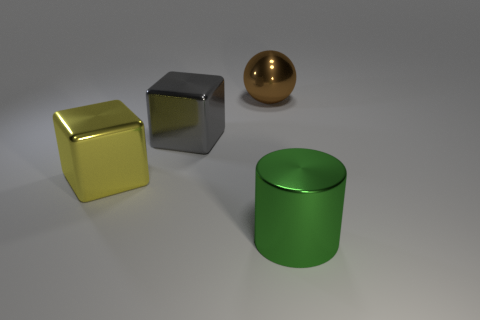Is the number of gray metallic objects to the left of the gray shiny object the same as the number of purple shiny blocks?
Ensure brevity in your answer.  Yes. What shape is the large metallic thing that is in front of the gray metal cube and on the left side of the brown ball?
Your response must be concise. Cube. Do the gray thing and the green shiny cylinder have the same size?
Your answer should be very brief. Yes. Is there a big purple sphere made of the same material as the large brown sphere?
Your answer should be compact. No. How many things are in front of the large brown ball and right of the big yellow metallic thing?
Offer a very short reply. 2. There is a thing on the right side of the large brown metallic sphere; what is it made of?
Your answer should be compact. Metal. How many things have the same color as the big metal cylinder?
Give a very brief answer. 0. What size is the green object that is the same material as the sphere?
Your answer should be very brief. Large. What number of objects are either large green metallic things or large cubes?
Keep it short and to the point. 3. The cube that is in front of the large gray metallic thing is what color?
Your answer should be very brief. Yellow. 